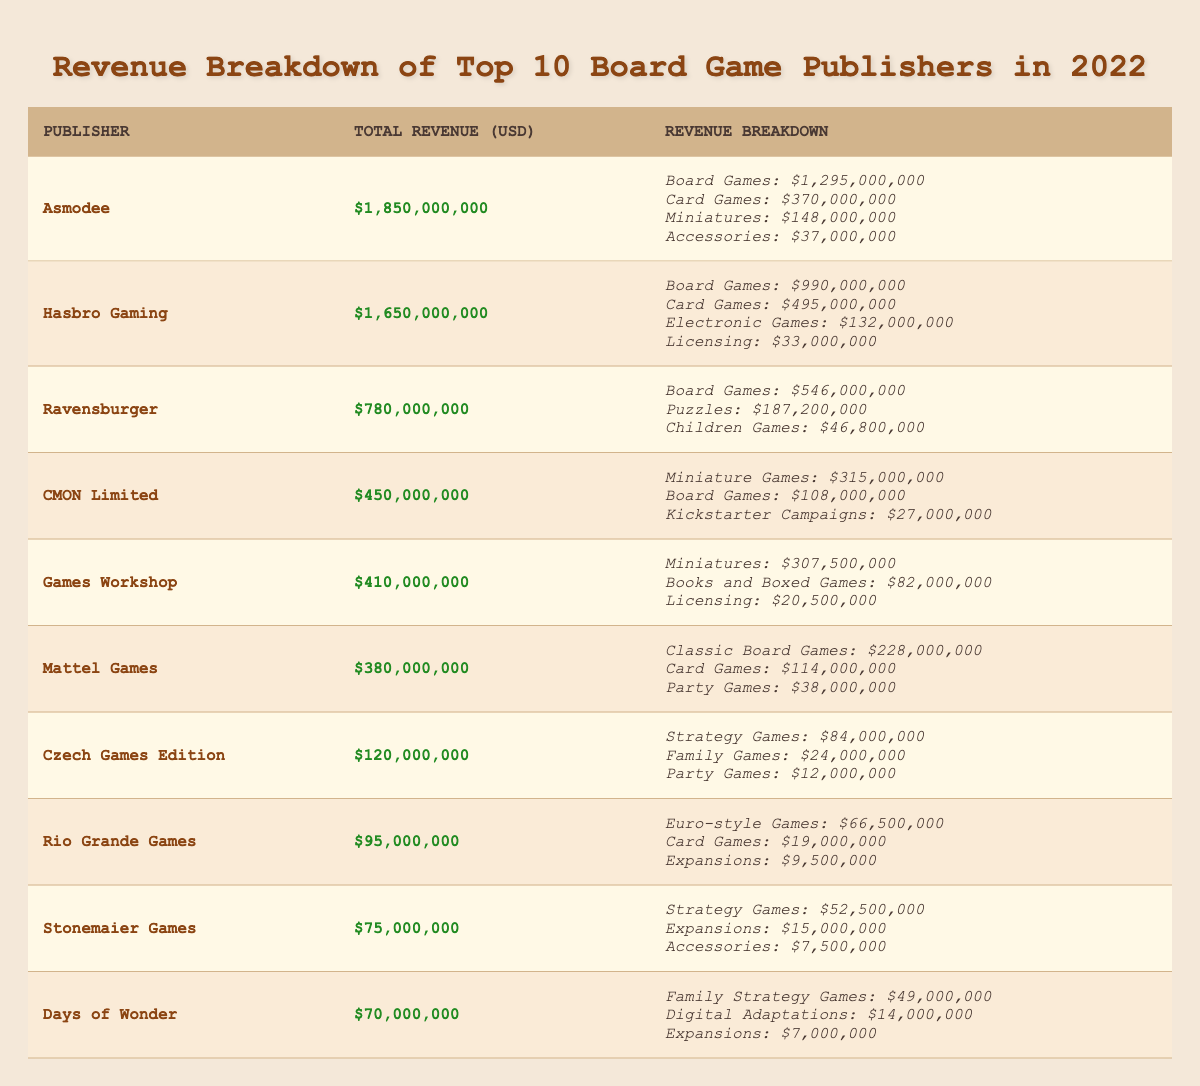What is the total revenue of Asmodee? The total revenue of Asmodee is directly stated in the table, listed under the column for total revenue. It shows $1,850,000,000.
Answer: 1,850,000,000 Which publisher has the highest revenue from board games? The highest revenue from board games is found by looking at the breakdown of board games across each publisher. Asmodee has the highest with $1,295,000,000.
Answer: Asmodee What percentage of total revenue does Hasbro Gaming earn from card games? To find the percentage, divide Hasbro Gaming's revenue from card games ($495,000,000) by their total revenue ($1,650,000,000) and multiply by 100. This gives (495,000,000 / 1,650,000,000) * 100 = 30%.
Answer: 30% Is CMON Limited's revenue from board games less than 20% of its total revenue? CMON Limited makes $108,000,000 from board games, which is calculated as a percentage of their total revenue ($450,000,000). This equals (108,000,000 / 450,000,000) * 100 = 24%, therefore it is not less than 20%.
Answer: No What is the total revenue from card games for the top three publishers? The total revenue from card games is summed for the top three publishers: Asmodee ($370,000,000), Hasbro Gaming ($495,000,000), and CMON Limited ($0, no card games listed). Adding these: 370,000,000 + 495,000,000 + 0 = 865,000,000.
Answer: 865,000,000 Which publisher earns the least total revenue and what is that revenue? By checking the total revenue for each publisher, we find that Rio Grande Games has the least revenue at $95,000,000.
Answer: 95,000,000 How much more revenue does Mattel Games earn from classic board games compared to party games? The revenue from classic board games is $228,000,000 and from party games is $38,000,000. The difference is calculated as 228,000,000 - 38,000,000 = 190,000,000.
Answer: 190,000,000 Does Games Workshop have more revenue from miniatures than Ravensburger has from board games? Games Workshop earns $307,500,000 from miniatures, while Ravensburger earns $546,000,000 from board games. Since 307,500,000 is less than 546,000,000, the answer is no.
Answer: No What is the average revenue of all publishers listed in the table? To find the average revenue, sum all total revenues: (1,850,000,000 + 1,650,000,000 + 780,000,000 + 450,000,000 + 410,000,000 + 380,000,000 + 120,000,000 + 95,000,000 + 75,000,000 + 70,000,000) = 5,510,000,000. There are 10 publishers, so the average revenue is 5,510,000,000 / 10 = 551,000,000.
Answer: 551,000,000 